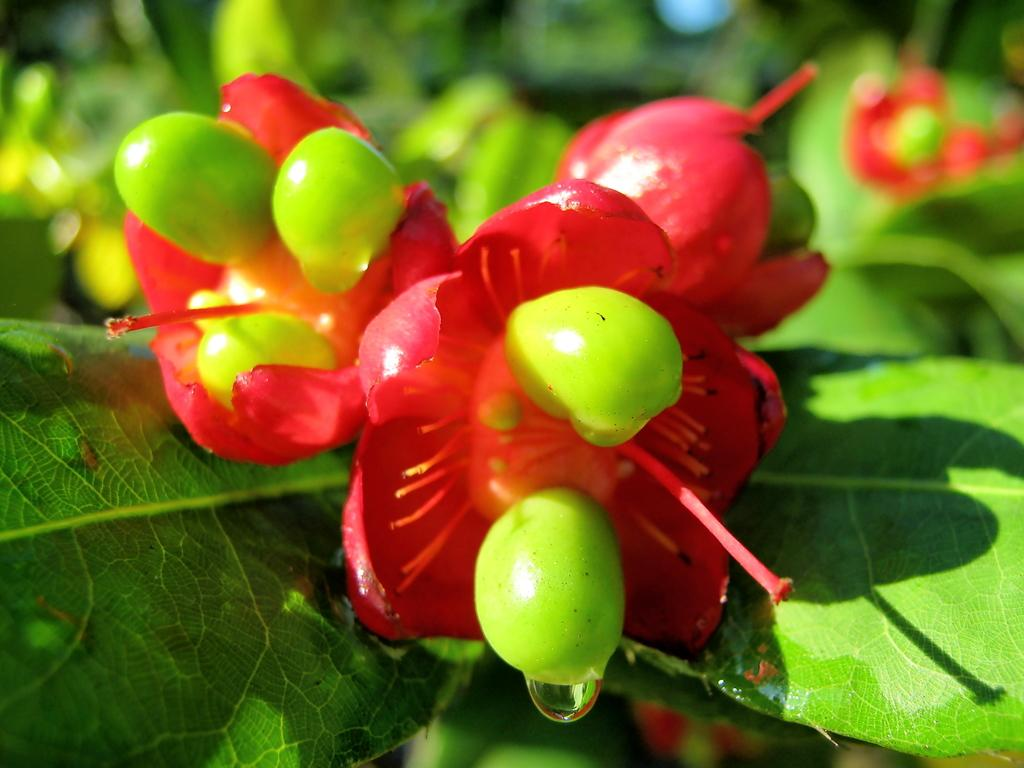What type of plant life can be seen in the image? There are leaves and flowers in the image. Can you describe the background of the image? The background of the image is blurry. What type of crate is visible in the image? There is no crate present in the image. What event is being shown in the image? The image does not depict any specific event; it simply features leaves and flowers with a blurry background. 